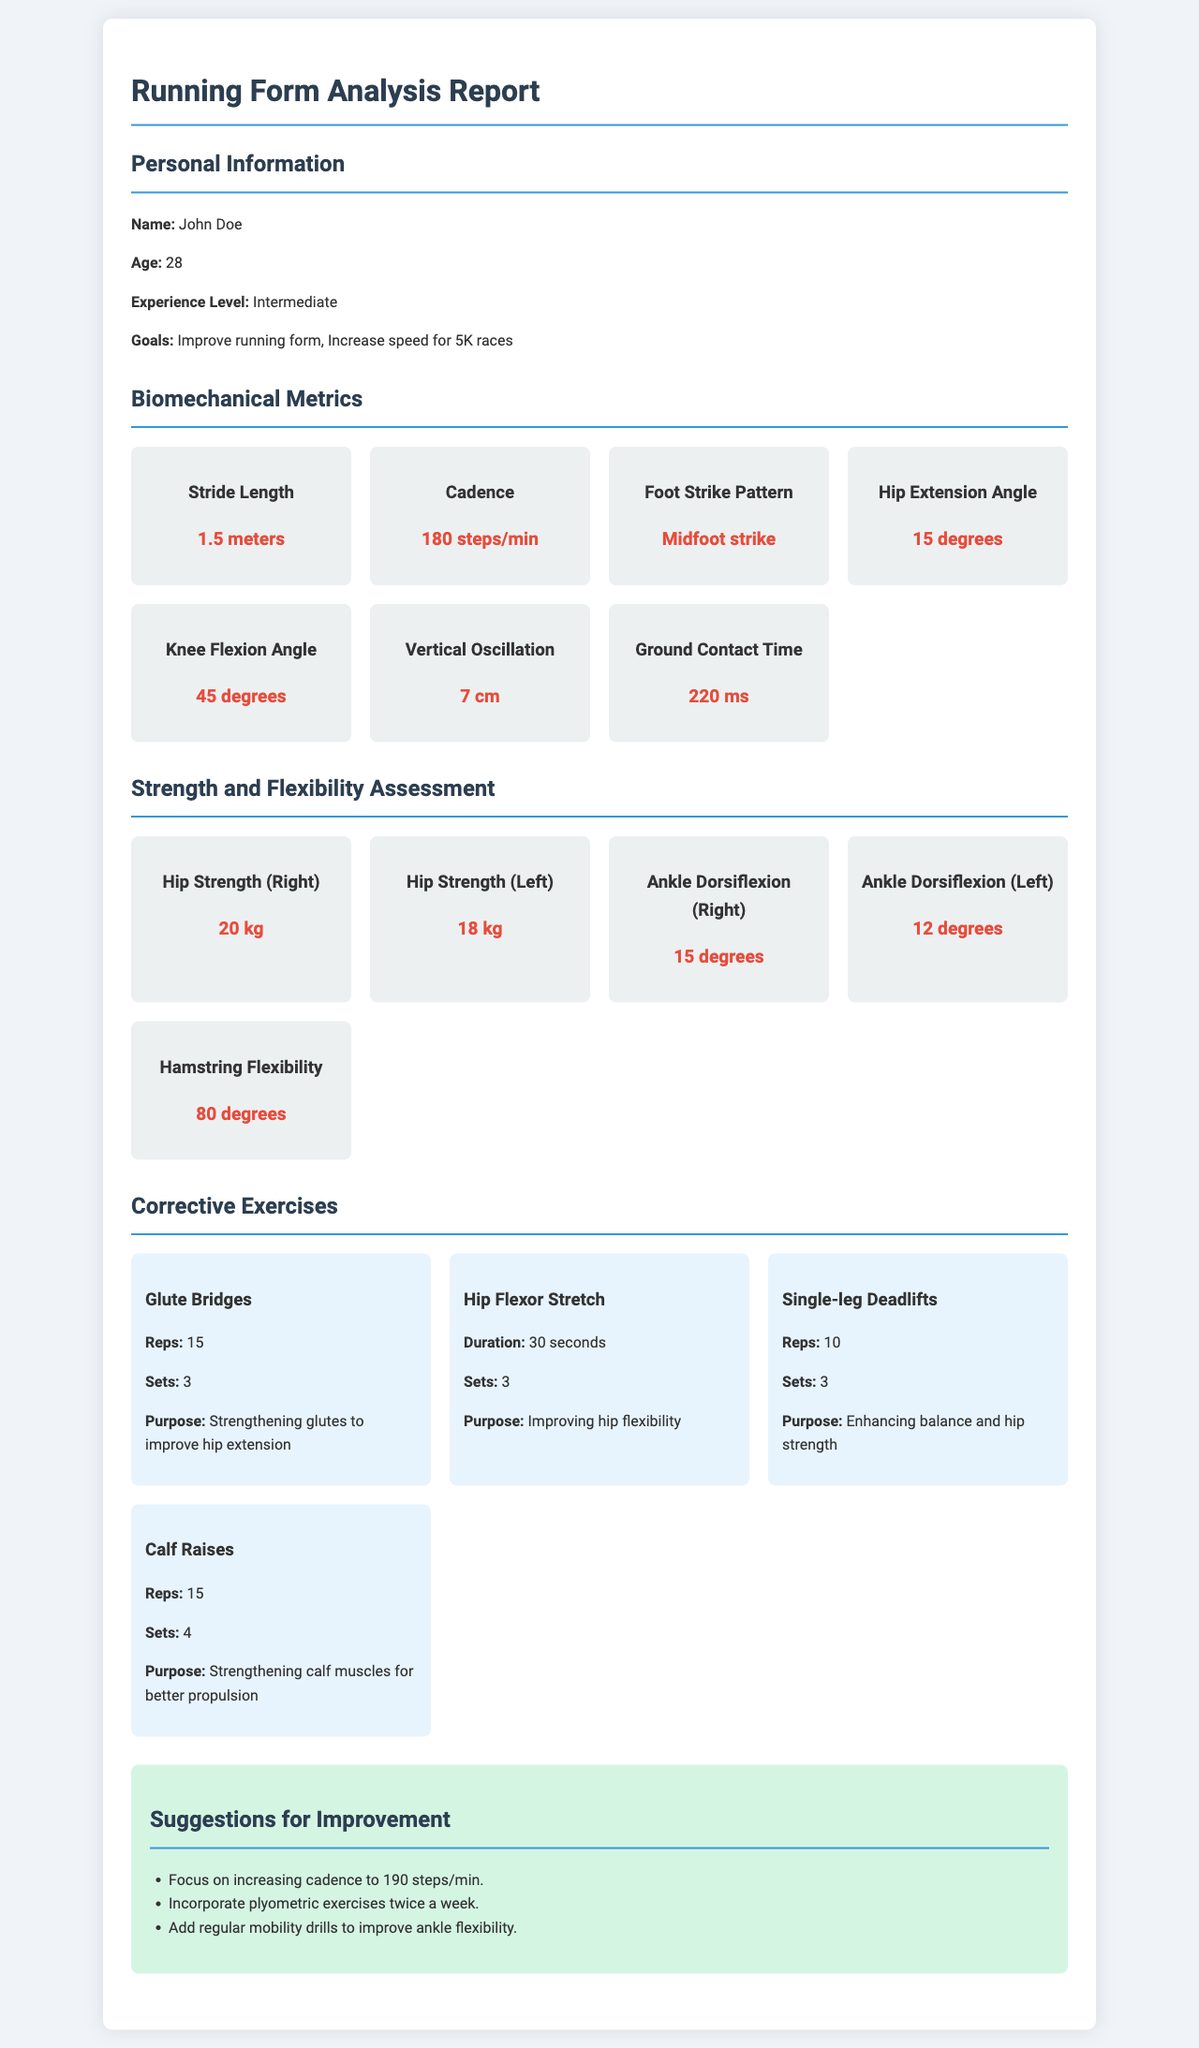what is the name of the individual analyzed? The document states the individual's name in the personal information section, which is John Doe.
Answer: John Doe what is the age of the individual? The age of the individual is mentioned in the personal information section of the report.
Answer: 28 what is the individual's cadence? The metric for cadence is provided under Biomechanical Metrics in the report.
Answer: 180 steps/min what is the hip extension angle? The hip extension angle can be found in the Biomechanical Metrics section of the analysis.
Answer: 15 degrees how many sets of Glute Bridges are recommended? The number of sets for Glute Bridges is listed under Corrective Exercises in the document.
Answer: 3 what is the purpose of Single-leg Deadlifts? The purpose of Single-leg Deadlifts is described in the corrective exercises section.
Answer: Enhancing balance and hip strength what is the suggested cadence to improve? The suggested cadence for improvement is highlighted in the Suggestions for Improvement section.
Answer: 190 steps/min how many degrees of ankle dorsiflexion does the left ankle have? The left ankle dorsiflexion measurement is mentioned in the Strength and Flexibility Assessment section.
Answer: 12 degrees what exercise is suggested to improve hip flexibility? The exercise aimed at improving hip flexibility is detailed in the Corrective Exercises section.
Answer: Hip Flexor Stretch 